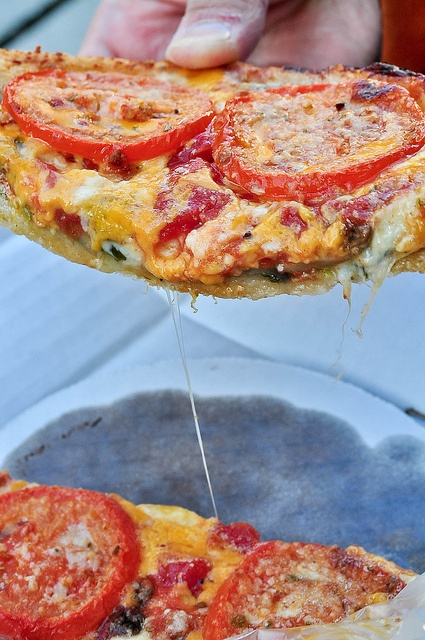Describe the objects in this image and their specific colors. I can see pizza in lightblue, tan, and brown tones, pizza in lightblue, brown, tan, and salmon tones, and people in lightblue, darkgray, maroon, brown, and lightpink tones in this image. 